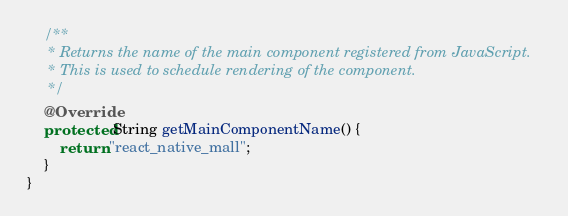<code> <loc_0><loc_0><loc_500><loc_500><_Java_>
    /**
     * Returns the name of the main component registered from JavaScript.
     * This is used to schedule rendering of the component.
     */
    @Override
    protected String getMainComponentName() {
        return "react_native_mall";
    }
}
</code> 